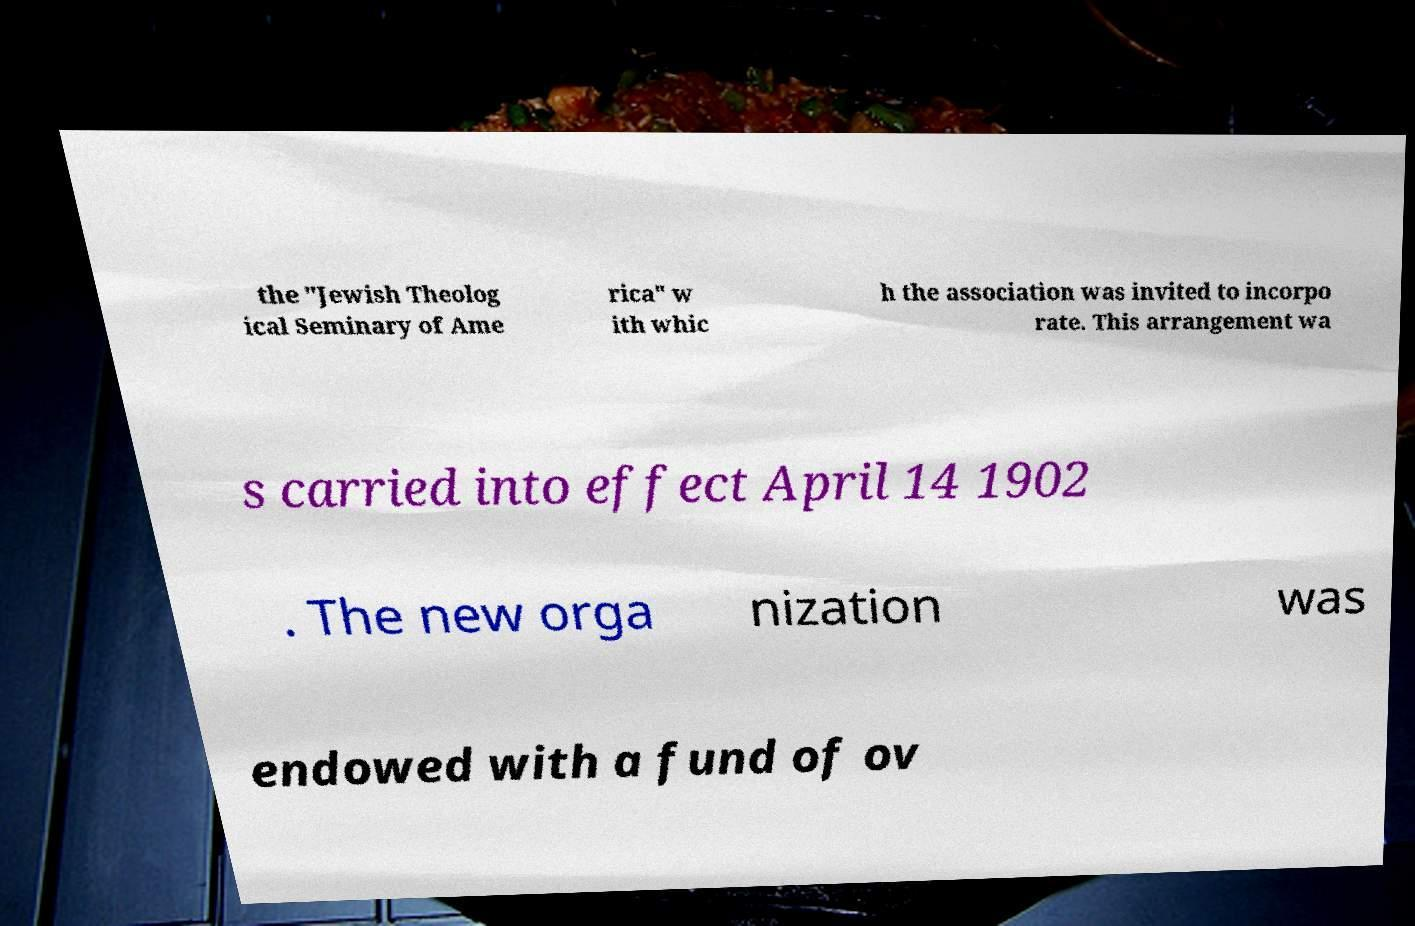Please identify and transcribe the text found in this image. the "Jewish Theolog ical Seminary of Ame rica" w ith whic h the association was invited to incorpo rate. This arrangement wa s carried into effect April 14 1902 . The new orga nization was endowed with a fund of ov 